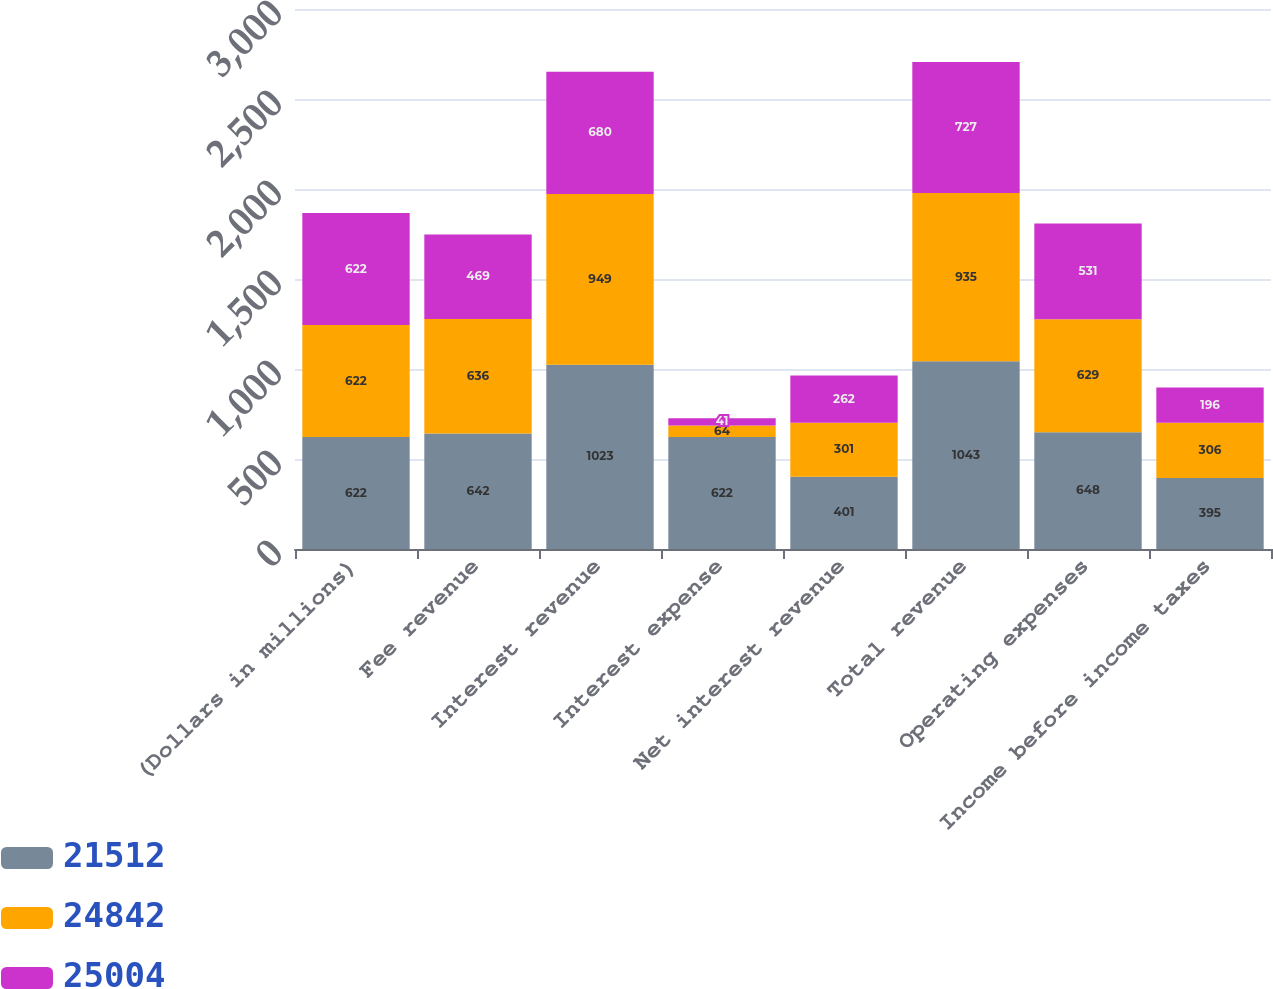Convert chart. <chart><loc_0><loc_0><loc_500><loc_500><stacked_bar_chart><ecel><fcel>(Dollars in millions)<fcel>Fee revenue<fcel>Interest revenue<fcel>Interest expense<fcel>Net interest revenue<fcel>Total revenue<fcel>Operating expenses<fcel>Income before income taxes<nl><fcel>21512<fcel>622<fcel>642<fcel>1023<fcel>622<fcel>401<fcel>1043<fcel>648<fcel>395<nl><fcel>24842<fcel>622<fcel>636<fcel>949<fcel>64<fcel>301<fcel>935<fcel>629<fcel>306<nl><fcel>25004<fcel>622<fcel>469<fcel>680<fcel>41<fcel>262<fcel>727<fcel>531<fcel>196<nl></chart> 